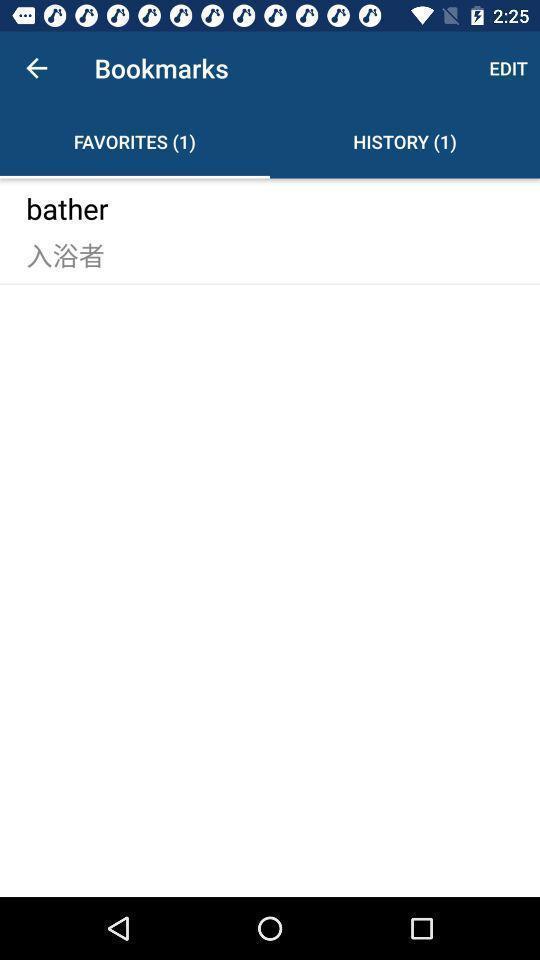What can you discern from this picture? Page showing favorites list in bookmarks. 